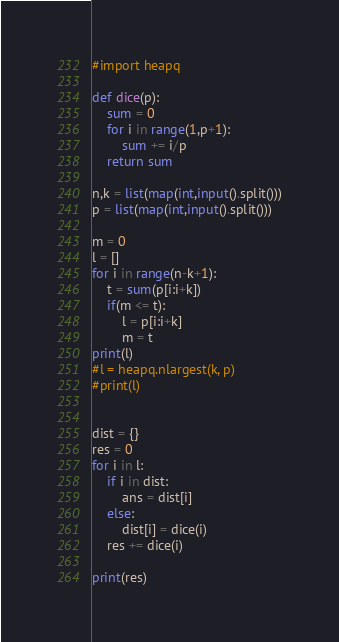<code> <loc_0><loc_0><loc_500><loc_500><_Python_>#import heapq

def dice(p):
    sum = 0
    for i in range(1,p+1):
        sum += i/p
    return sum

n,k = list(map(int,input().split()))
p = list(map(int,input().split()))

m = 0
l = []
for i in range(n-k+1):
    t = sum(p[i:i+k])
    if(m <= t):
        l = p[i:i+k]
        m = t
print(l)
#l = heapq.nlargest(k, p)
#print(l)


dist = {}
res = 0
for i in l:
    if i in dist:
        ans = dist[i]
    else:
        dist[i] = dice(i)
    res += dice(i)

print(res)









</code> 